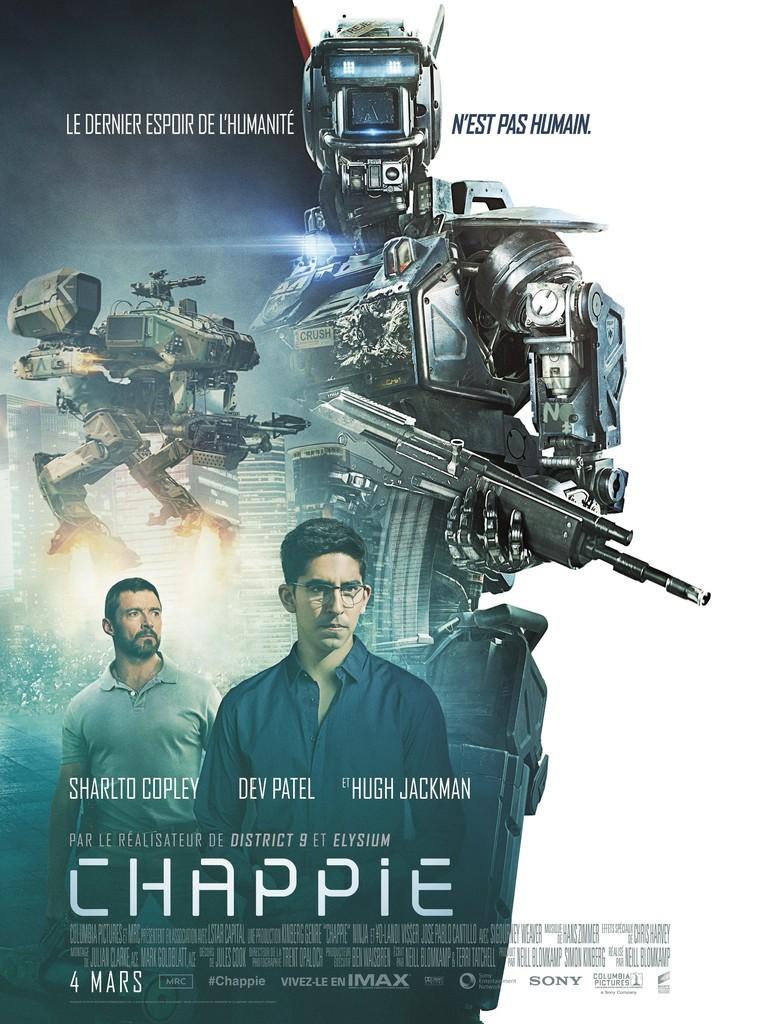Is chappie about robots?
Keep it short and to the point. Answering does not require reading text in the image. What actor's name is furthest to the right?
Ensure brevity in your answer.  Hugh jackman. 